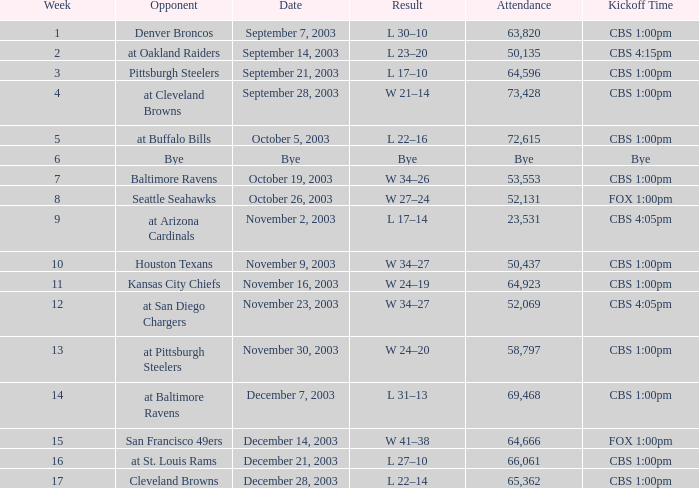What was the kickoff time on week 1? CBS 1:00pm. 